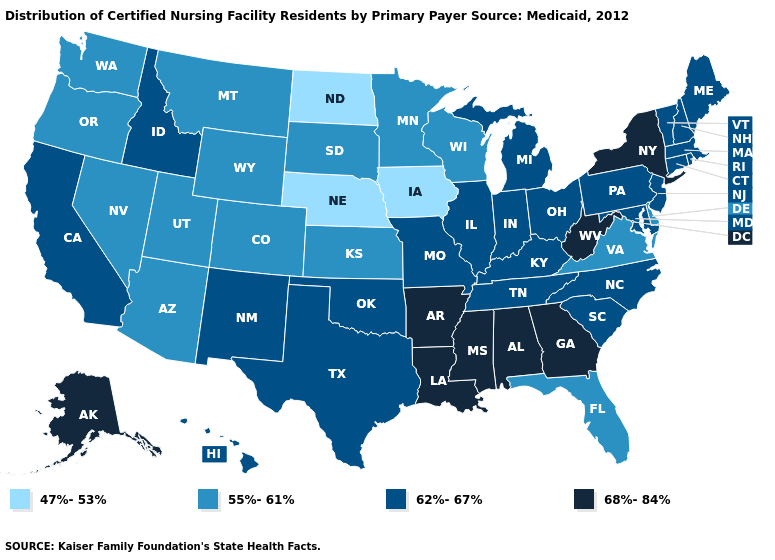Name the states that have a value in the range 62%-67%?
Keep it brief. California, Connecticut, Hawaii, Idaho, Illinois, Indiana, Kentucky, Maine, Maryland, Massachusetts, Michigan, Missouri, New Hampshire, New Jersey, New Mexico, North Carolina, Ohio, Oklahoma, Pennsylvania, Rhode Island, South Carolina, Tennessee, Texas, Vermont. Name the states that have a value in the range 55%-61%?
Answer briefly. Arizona, Colorado, Delaware, Florida, Kansas, Minnesota, Montana, Nevada, Oregon, South Dakota, Utah, Virginia, Washington, Wisconsin, Wyoming. Does Louisiana have a lower value than Ohio?
Write a very short answer. No. Does New York have the highest value in the Northeast?
Write a very short answer. Yes. What is the value of Montana?
Write a very short answer. 55%-61%. Which states have the highest value in the USA?
Keep it brief. Alabama, Alaska, Arkansas, Georgia, Louisiana, Mississippi, New York, West Virginia. Which states have the lowest value in the USA?
Give a very brief answer. Iowa, Nebraska, North Dakota. Does the map have missing data?
Quick response, please. No. What is the value of Virginia?
Keep it brief. 55%-61%. Does Nebraska have the lowest value in the USA?
Concise answer only. Yes. What is the highest value in the USA?
Quick response, please. 68%-84%. What is the lowest value in states that border Utah?
Keep it brief. 55%-61%. Among the states that border Michigan , does Indiana have the lowest value?
Concise answer only. No. Which states have the highest value in the USA?
Write a very short answer. Alabama, Alaska, Arkansas, Georgia, Louisiana, Mississippi, New York, West Virginia. Name the states that have a value in the range 62%-67%?
Keep it brief. California, Connecticut, Hawaii, Idaho, Illinois, Indiana, Kentucky, Maine, Maryland, Massachusetts, Michigan, Missouri, New Hampshire, New Jersey, New Mexico, North Carolina, Ohio, Oklahoma, Pennsylvania, Rhode Island, South Carolina, Tennessee, Texas, Vermont. 